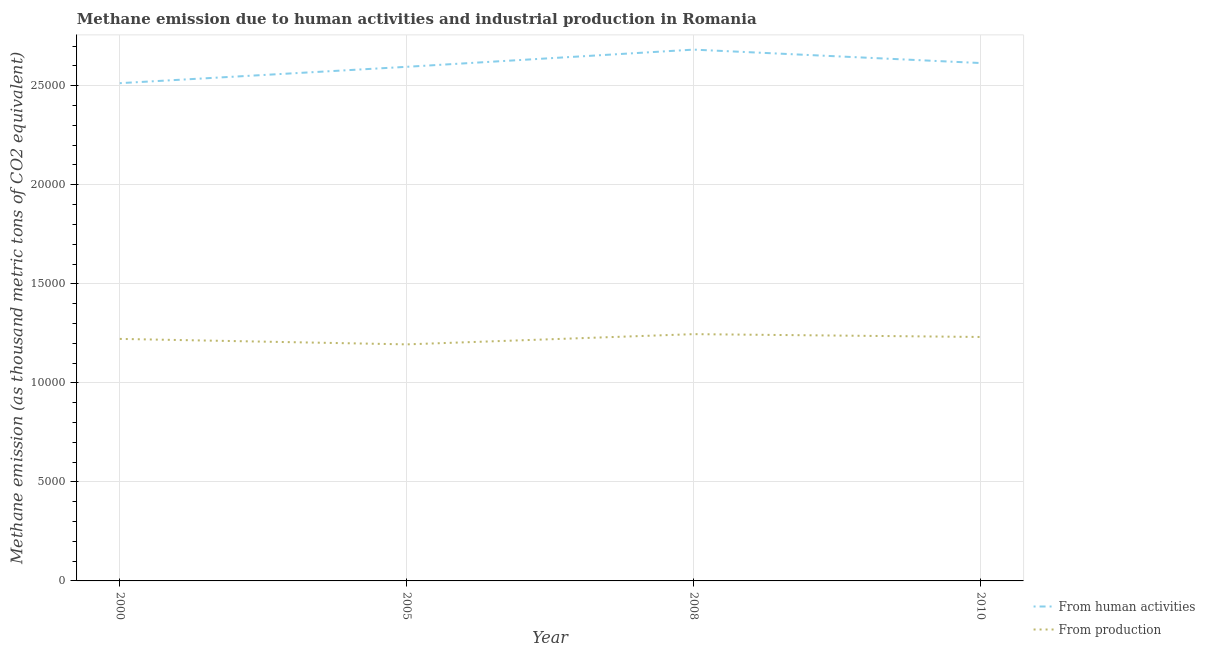How many different coloured lines are there?
Ensure brevity in your answer.  2. Does the line corresponding to amount of emissions from human activities intersect with the line corresponding to amount of emissions generated from industries?
Your answer should be very brief. No. What is the amount of emissions from human activities in 2008?
Your response must be concise. 2.68e+04. Across all years, what is the maximum amount of emissions generated from industries?
Give a very brief answer. 1.25e+04. Across all years, what is the minimum amount of emissions from human activities?
Give a very brief answer. 2.51e+04. What is the total amount of emissions generated from industries in the graph?
Keep it short and to the point. 4.89e+04. What is the difference between the amount of emissions generated from industries in 2000 and that in 2005?
Provide a succinct answer. 276.6. What is the difference between the amount of emissions generated from industries in 2010 and the amount of emissions from human activities in 2008?
Provide a succinct answer. -1.45e+04. What is the average amount of emissions from human activities per year?
Your response must be concise. 2.60e+04. In the year 2000, what is the difference between the amount of emissions from human activities and amount of emissions generated from industries?
Give a very brief answer. 1.29e+04. In how many years, is the amount of emissions generated from industries greater than 20000 thousand metric tons?
Your response must be concise. 0. What is the ratio of the amount of emissions generated from industries in 2005 to that in 2008?
Provide a short and direct response. 0.96. What is the difference between the highest and the second highest amount of emissions from human activities?
Offer a very short reply. 677.8. What is the difference between the highest and the lowest amount of emissions generated from industries?
Provide a short and direct response. 516.5. Is the sum of the amount of emissions from human activities in 2000 and 2010 greater than the maximum amount of emissions generated from industries across all years?
Provide a succinct answer. Yes. Does the amount of emissions from human activities monotonically increase over the years?
Your response must be concise. No. Is the amount of emissions from human activities strictly greater than the amount of emissions generated from industries over the years?
Keep it short and to the point. Yes. Is the amount of emissions generated from industries strictly less than the amount of emissions from human activities over the years?
Make the answer very short. Yes. How many lines are there?
Provide a short and direct response. 2. How many years are there in the graph?
Ensure brevity in your answer.  4. Does the graph contain any zero values?
Your answer should be very brief. No. Does the graph contain grids?
Give a very brief answer. Yes. Where does the legend appear in the graph?
Keep it short and to the point. Bottom right. How many legend labels are there?
Your answer should be compact. 2. How are the legend labels stacked?
Offer a terse response. Vertical. What is the title of the graph?
Ensure brevity in your answer.  Methane emission due to human activities and industrial production in Romania. What is the label or title of the Y-axis?
Your answer should be very brief. Methane emission (as thousand metric tons of CO2 equivalent). What is the Methane emission (as thousand metric tons of CO2 equivalent) in From human activities in 2000?
Give a very brief answer. 2.51e+04. What is the Methane emission (as thousand metric tons of CO2 equivalent) in From production in 2000?
Offer a terse response. 1.22e+04. What is the Methane emission (as thousand metric tons of CO2 equivalent) of From human activities in 2005?
Offer a terse response. 2.60e+04. What is the Methane emission (as thousand metric tons of CO2 equivalent) in From production in 2005?
Keep it short and to the point. 1.19e+04. What is the Methane emission (as thousand metric tons of CO2 equivalent) of From human activities in 2008?
Ensure brevity in your answer.  2.68e+04. What is the Methane emission (as thousand metric tons of CO2 equivalent) in From production in 2008?
Provide a short and direct response. 1.25e+04. What is the Methane emission (as thousand metric tons of CO2 equivalent) of From human activities in 2010?
Make the answer very short. 2.61e+04. What is the Methane emission (as thousand metric tons of CO2 equivalent) of From production in 2010?
Keep it short and to the point. 1.23e+04. Across all years, what is the maximum Methane emission (as thousand metric tons of CO2 equivalent) of From human activities?
Give a very brief answer. 2.68e+04. Across all years, what is the maximum Methane emission (as thousand metric tons of CO2 equivalent) in From production?
Make the answer very short. 1.25e+04. Across all years, what is the minimum Methane emission (as thousand metric tons of CO2 equivalent) of From human activities?
Give a very brief answer. 2.51e+04. Across all years, what is the minimum Methane emission (as thousand metric tons of CO2 equivalent) in From production?
Provide a short and direct response. 1.19e+04. What is the total Methane emission (as thousand metric tons of CO2 equivalent) in From human activities in the graph?
Offer a terse response. 1.04e+05. What is the total Methane emission (as thousand metric tons of CO2 equivalent) of From production in the graph?
Make the answer very short. 4.89e+04. What is the difference between the Methane emission (as thousand metric tons of CO2 equivalent) in From human activities in 2000 and that in 2005?
Make the answer very short. -826. What is the difference between the Methane emission (as thousand metric tons of CO2 equivalent) in From production in 2000 and that in 2005?
Keep it short and to the point. 276.6. What is the difference between the Methane emission (as thousand metric tons of CO2 equivalent) in From human activities in 2000 and that in 2008?
Give a very brief answer. -1694.4. What is the difference between the Methane emission (as thousand metric tons of CO2 equivalent) in From production in 2000 and that in 2008?
Offer a terse response. -239.9. What is the difference between the Methane emission (as thousand metric tons of CO2 equivalent) of From human activities in 2000 and that in 2010?
Provide a succinct answer. -1016.6. What is the difference between the Methane emission (as thousand metric tons of CO2 equivalent) of From production in 2000 and that in 2010?
Keep it short and to the point. -96.6. What is the difference between the Methane emission (as thousand metric tons of CO2 equivalent) of From human activities in 2005 and that in 2008?
Your answer should be very brief. -868.4. What is the difference between the Methane emission (as thousand metric tons of CO2 equivalent) in From production in 2005 and that in 2008?
Your answer should be compact. -516.5. What is the difference between the Methane emission (as thousand metric tons of CO2 equivalent) in From human activities in 2005 and that in 2010?
Provide a short and direct response. -190.6. What is the difference between the Methane emission (as thousand metric tons of CO2 equivalent) of From production in 2005 and that in 2010?
Your answer should be very brief. -373.2. What is the difference between the Methane emission (as thousand metric tons of CO2 equivalent) of From human activities in 2008 and that in 2010?
Keep it short and to the point. 677.8. What is the difference between the Methane emission (as thousand metric tons of CO2 equivalent) in From production in 2008 and that in 2010?
Your response must be concise. 143.3. What is the difference between the Methane emission (as thousand metric tons of CO2 equivalent) of From human activities in 2000 and the Methane emission (as thousand metric tons of CO2 equivalent) of From production in 2005?
Make the answer very short. 1.32e+04. What is the difference between the Methane emission (as thousand metric tons of CO2 equivalent) in From human activities in 2000 and the Methane emission (as thousand metric tons of CO2 equivalent) in From production in 2008?
Your answer should be compact. 1.27e+04. What is the difference between the Methane emission (as thousand metric tons of CO2 equivalent) of From human activities in 2000 and the Methane emission (as thousand metric tons of CO2 equivalent) of From production in 2010?
Your answer should be compact. 1.28e+04. What is the difference between the Methane emission (as thousand metric tons of CO2 equivalent) in From human activities in 2005 and the Methane emission (as thousand metric tons of CO2 equivalent) in From production in 2008?
Offer a very short reply. 1.35e+04. What is the difference between the Methane emission (as thousand metric tons of CO2 equivalent) in From human activities in 2005 and the Methane emission (as thousand metric tons of CO2 equivalent) in From production in 2010?
Your answer should be compact. 1.36e+04. What is the difference between the Methane emission (as thousand metric tons of CO2 equivalent) of From human activities in 2008 and the Methane emission (as thousand metric tons of CO2 equivalent) of From production in 2010?
Your answer should be very brief. 1.45e+04. What is the average Methane emission (as thousand metric tons of CO2 equivalent) of From human activities per year?
Make the answer very short. 2.60e+04. What is the average Methane emission (as thousand metric tons of CO2 equivalent) of From production per year?
Offer a very short reply. 1.22e+04. In the year 2000, what is the difference between the Methane emission (as thousand metric tons of CO2 equivalent) of From human activities and Methane emission (as thousand metric tons of CO2 equivalent) of From production?
Offer a terse response. 1.29e+04. In the year 2005, what is the difference between the Methane emission (as thousand metric tons of CO2 equivalent) in From human activities and Methane emission (as thousand metric tons of CO2 equivalent) in From production?
Provide a succinct answer. 1.40e+04. In the year 2008, what is the difference between the Methane emission (as thousand metric tons of CO2 equivalent) in From human activities and Methane emission (as thousand metric tons of CO2 equivalent) in From production?
Ensure brevity in your answer.  1.44e+04. In the year 2010, what is the difference between the Methane emission (as thousand metric tons of CO2 equivalent) in From human activities and Methane emission (as thousand metric tons of CO2 equivalent) in From production?
Offer a very short reply. 1.38e+04. What is the ratio of the Methane emission (as thousand metric tons of CO2 equivalent) in From human activities in 2000 to that in 2005?
Offer a very short reply. 0.97. What is the ratio of the Methane emission (as thousand metric tons of CO2 equivalent) in From production in 2000 to that in 2005?
Offer a terse response. 1.02. What is the ratio of the Methane emission (as thousand metric tons of CO2 equivalent) in From human activities in 2000 to that in 2008?
Provide a short and direct response. 0.94. What is the ratio of the Methane emission (as thousand metric tons of CO2 equivalent) in From production in 2000 to that in 2008?
Make the answer very short. 0.98. What is the ratio of the Methane emission (as thousand metric tons of CO2 equivalent) in From human activities in 2000 to that in 2010?
Your answer should be compact. 0.96. What is the ratio of the Methane emission (as thousand metric tons of CO2 equivalent) in From human activities in 2005 to that in 2008?
Provide a succinct answer. 0.97. What is the ratio of the Methane emission (as thousand metric tons of CO2 equivalent) of From production in 2005 to that in 2008?
Give a very brief answer. 0.96. What is the ratio of the Methane emission (as thousand metric tons of CO2 equivalent) of From production in 2005 to that in 2010?
Your answer should be very brief. 0.97. What is the ratio of the Methane emission (as thousand metric tons of CO2 equivalent) in From human activities in 2008 to that in 2010?
Make the answer very short. 1.03. What is the ratio of the Methane emission (as thousand metric tons of CO2 equivalent) in From production in 2008 to that in 2010?
Offer a terse response. 1.01. What is the difference between the highest and the second highest Methane emission (as thousand metric tons of CO2 equivalent) of From human activities?
Offer a very short reply. 677.8. What is the difference between the highest and the second highest Methane emission (as thousand metric tons of CO2 equivalent) in From production?
Make the answer very short. 143.3. What is the difference between the highest and the lowest Methane emission (as thousand metric tons of CO2 equivalent) in From human activities?
Keep it short and to the point. 1694.4. What is the difference between the highest and the lowest Methane emission (as thousand metric tons of CO2 equivalent) in From production?
Ensure brevity in your answer.  516.5. 